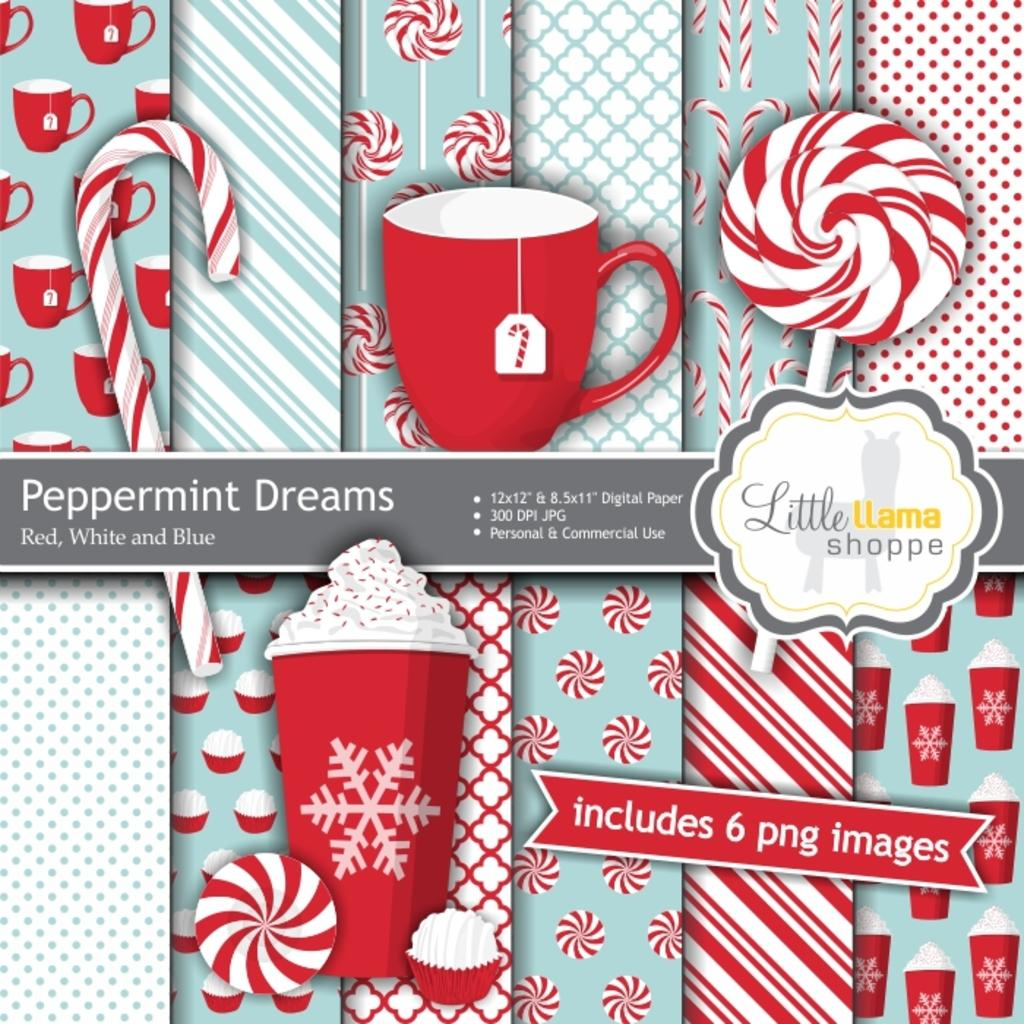What is featured on the poster in the image? There is a poster in the image, and it contains images of cups. What else can be seen on the poster besides the images of cups? There is text present on the poster. How many apples are visible on the poster in the image? There are no apples present on the poster in the image; it features images of cups. What type of sand can be seen being measured on the poster in the image? There is no sand or measuring activity present on the poster in the image. 